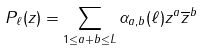Convert formula to latex. <formula><loc_0><loc_0><loc_500><loc_500>P _ { \ell } ( z ) = \sum _ { 1 \leq a + b \leq L } \alpha _ { a , b } ( \ell ) z ^ { a } \overline { z } ^ { b }</formula> 